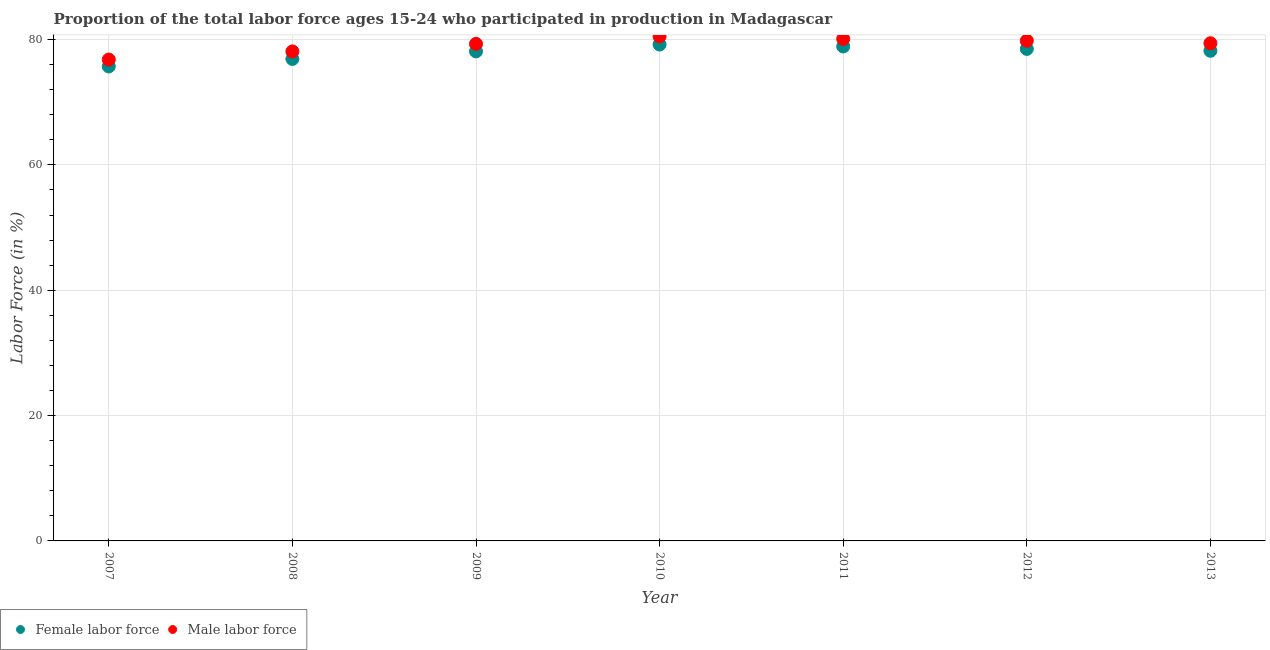How many different coloured dotlines are there?
Make the answer very short. 2. What is the percentage of female labor force in 2010?
Your answer should be compact. 79.2. Across all years, what is the maximum percentage of female labor force?
Your answer should be very brief. 79.2. Across all years, what is the minimum percentage of male labour force?
Your answer should be very brief. 76.8. In which year was the percentage of female labor force maximum?
Offer a terse response. 2010. What is the total percentage of female labor force in the graph?
Ensure brevity in your answer.  545.5. What is the difference between the percentage of male labour force in 2008 and that in 2010?
Give a very brief answer. -2.4. What is the difference between the percentage of male labour force in 2010 and the percentage of female labor force in 2013?
Offer a terse response. 2.3. What is the average percentage of male labour force per year?
Provide a succinct answer. 79.14. In the year 2009, what is the difference between the percentage of female labor force and percentage of male labour force?
Ensure brevity in your answer.  -1.2. What is the ratio of the percentage of male labour force in 2008 to that in 2012?
Provide a succinct answer. 0.98. Is the percentage of female labor force in 2007 less than that in 2008?
Offer a very short reply. Yes. Is the difference between the percentage of female labor force in 2011 and 2013 greater than the difference between the percentage of male labour force in 2011 and 2013?
Your answer should be very brief. Yes. What is the difference between the highest and the second highest percentage of male labour force?
Give a very brief answer. 0.4. What is the difference between the highest and the lowest percentage of male labour force?
Give a very brief answer. 3.7. In how many years, is the percentage of male labour force greater than the average percentage of male labour force taken over all years?
Keep it short and to the point. 5. Is the percentage of female labor force strictly less than the percentage of male labour force over the years?
Keep it short and to the point. Yes. How many dotlines are there?
Keep it short and to the point. 2. What is the difference between two consecutive major ticks on the Y-axis?
Offer a very short reply. 20. Does the graph contain any zero values?
Your response must be concise. No. Where does the legend appear in the graph?
Provide a succinct answer. Bottom left. How many legend labels are there?
Offer a terse response. 2. What is the title of the graph?
Ensure brevity in your answer.  Proportion of the total labor force ages 15-24 who participated in production in Madagascar. What is the Labor Force (in %) of Female labor force in 2007?
Your answer should be very brief. 75.7. What is the Labor Force (in %) in Male labor force in 2007?
Make the answer very short. 76.8. What is the Labor Force (in %) of Female labor force in 2008?
Offer a terse response. 76.9. What is the Labor Force (in %) of Male labor force in 2008?
Your response must be concise. 78.1. What is the Labor Force (in %) of Female labor force in 2009?
Your answer should be very brief. 78.1. What is the Labor Force (in %) of Male labor force in 2009?
Offer a terse response. 79.3. What is the Labor Force (in %) in Female labor force in 2010?
Offer a terse response. 79.2. What is the Labor Force (in %) of Male labor force in 2010?
Your response must be concise. 80.5. What is the Labor Force (in %) in Female labor force in 2011?
Ensure brevity in your answer.  78.9. What is the Labor Force (in %) in Male labor force in 2011?
Keep it short and to the point. 80.1. What is the Labor Force (in %) of Female labor force in 2012?
Offer a very short reply. 78.5. What is the Labor Force (in %) of Male labor force in 2012?
Your answer should be compact. 79.8. What is the Labor Force (in %) of Female labor force in 2013?
Give a very brief answer. 78.2. What is the Labor Force (in %) in Male labor force in 2013?
Offer a very short reply. 79.4. Across all years, what is the maximum Labor Force (in %) in Female labor force?
Ensure brevity in your answer.  79.2. Across all years, what is the maximum Labor Force (in %) in Male labor force?
Offer a terse response. 80.5. Across all years, what is the minimum Labor Force (in %) of Female labor force?
Keep it short and to the point. 75.7. Across all years, what is the minimum Labor Force (in %) of Male labor force?
Your answer should be compact. 76.8. What is the total Labor Force (in %) of Female labor force in the graph?
Make the answer very short. 545.5. What is the total Labor Force (in %) in Male labor force in the graph?
Give a very brief answer. 554. What is the difference between the Labor Force (in %) in Female labor force in 2007 and that in 2008?
Your answer should be compact. -1.2. What is the difference between the Labor Force (in %) of Male labor force in 2007 and that in 2009?
Make the answer very short. -2.5. What is the difference between the Labor Force (in %) of Female labor force in 2007 and that in 2010?
Keep it short and to the point. -3.5. What is the difference between the Labor Force (in %) of Male labor force in 2007 and that in 2011?
Offer a very short reply. -3.3. What is the difference between the Labor Force (in %) of Male labor force in 2007 and that in 2012?
Give a very brief answer. -3. What is the difference between the Labor Force (in %) in Female labor force in 2007 and that in 2013?
Offer a very short reply. -2.5. What is the difference between the Labor Force (in %) of Male labor force in 2008 and that in 2010?
Offer a very short reply. -2.4. What is the difference between the Labor Force (in %) in Female labor force in 2008 and that in 2011?
Your response must be concise. -2. What is the difference between the Labor Force (in %) of Male labor force in 2008 and that in 2011?
Offer a terse response. -2. What is the difference between the Labor Force (in %) in Female labor force in 2008 and that in 2012?
Your response must be concise. -1.6. What is the difference between the Labor Force (in %) in Female labor force in 2009 and that in 2011?
Your answer should be compact. -0.8. What is the difference between the Labor Force (in %) in Male labor force in 2009 and that in 2012?
Your answer should be compact. -0.5. What is the difference between the Labor Force (in %) in Female labor force in 2009 and that in 2013?
Offer a terse response. -0.1. What is the difference between the Labor Force (in %) of Female labor force in 2010 and that in 2013?
Give a very brief answer. 1. What is the difference between the Labor Force (in %) in Male labor force in 2010 and that in 2013?
Provide a short and direct response. 1.1. What is the difference between the Labor Force (in %) of Male labor force in 2011 and that in 2012?
Offer a very short reply. 0.3. What is the difference between the Labor Force (in %) in Male labor force in 2011 and that in 2013?
Your response must be concise. 0.7. What is the difference between the Labor Force (in %) in Female labor force in 2007 and the Labor Force (in %) in Male labor force in 2009?
Give a very brief answer. -3.6. What is the difference between the Labor Force (in %) in Female labor force in 2007 and the Labor Force (in %) in Male labor force in 2011?
Your answer should be compact. -4.4. What is the difference between the Labor Force (in %) of Female labor force in 2008 and the Labor Force (in %) of Male labor force in 2011?
Your answer should be very brief. -3.2. What is the difference between the Labor Force (in %) in Female labor force in 2009 and the Labor Force (in %) in Male labor force in 2010?
Ensure brevity in your answer.  -2.4. What is the difference between the Labor Force (in %) in Female labor force in 2009 and the Labor Force (in %) in Male labor force in 2013?
Offer a terse response. -1.3. What is the difference between the Labor Force (in %) in Female labor force in 2011 and the Labor Force (in %) in Male labor force in 2012?
Ensure brevity in your answer.  -0.9. What is the average Labor Force (in %) of Female labor force per year?
Your answer should be very brief. 77.93. What is the average Labor Force (in %) of Male labor force per year?
Keep it short and to the point. 79.14. In the year 2007, what is the difference between the Labor Force (in %) of Female labor force and Labor Force (in %) of Male labor force?
Your response must be concise. -1.1. In the year 2008, what is the difference between the Labor Force (in %) in Female labor force and Labor Force (in %) in Male labor force?
Offer a very short reply. -1.2. In the year 2010, what is the difference between the Labor Force (in %) of Female labor force and Labor Force (in %) of Male labor force?
Your answer should be very brief. -1.3. In the year 2012, what is the difference between the Labor Force (in %) in Female labor force and Labor Force (in %) in Male labor force?
Give a very brief answer. -1.3. What is the ratio of the Labor Force (in %) in Female labor force in 2007 to that in 2008?
Provide a succinct answer. 0.98. What is the ratio of the Labor Force (in %) in Male labor force in 2007 to that in 2008?
Keep it short and to the point. 0.98. What is the ratio of the Labor Force (in %) of Female labor force in 2007 to that in 2009?
Keep it short and to the point. 0.97. What is the ratio of the Labor Force (in %) of Male labor force in 2007 to that in 2009?
Provide a succinct answer. 0.97. What is the ratio of the Labor Force (in %) of Female labor force in 2007 to that in 2010?
Your answer should be very brief. 0.96. What is the ratio of the Labor Force (in %) in Male labor force in 2007 to that in 2010?
Ensure brevity in your answer.  0.95. What is the ratio of the Labor Force (in %) of Female labor force in 2007 to that in 2011?
Keep it short and to the point. 0.96. What is the ratio of the Labor Force (in %) of Male labor force in 2007 to that in 2011?
Provide a succinct answer. 0.96. What is the ratio of the Labor Force (in %) of Male labor force in 2007 to that in 2012?
Give a very brief answer. 0.96. What is the ratio of the Labor Force (in %) of Male labor force in 2007 to that in 2013?
Your answer should be compact. 0.97. What is the ratio of the Labor Force (in %) of Female labor force in 2008 to that in 2009?
Provide a succinct answer. 0.98. What is the ratio of the Labor Force (in %) of Male labor force in 2008 to that in 2009?
Your answer should be compact. 0.98. What is the ratio of the Labor Force (in %) in Male labor force in 2008 to that in 2010?
Offer a very short reply. 0.97. What is the ratio of the Labor Force (in %) of Female labor force in 2008 to that in 2011?
Offer a very short reply. 0.97. What is the ratio of the Labor Force (in %) in Female labor force in 2008 to that in 2012?
Offer a very short reply. 0.98. What is the ratio of the Labor Force (in %) in Male labor force in 2008 to that in 2012?
Ensure brevity in your answer.  0.98. What is the ratio of the Labor Force (in %) in Female labor force in 2008 to that in 2013?
Your answer should be very brief. 0.98. What is the ratio of the Labor Force (in %) in Male labor force in 2008 to that in 2013?
Keep it short and to the point. 0.98. What is the ratio of the Labor Force (in %) of Female labor force in 2009 to that in 2010?
Offer a terse response. 0.99. What is the ratio of the Labor Force (in %) of Male labor force in 2009 to that in 2010?
Keep it short and to the point. 0.99. What is the ratio of the Labor Force (in %) in Female labor force in 2009 to that in 2011?
Offer a very short reply. 0.99. What is the ratio of the Labor Force (in %) of Male labor force in 2009 to that in 2011?
Offer a very short reply. 0.99. What is the ratio of the Labor Force (in %) of Female labor force in 2010 to that in 2011?
Your answer should be very brief. 1. What is the ratio of the Labor Force (in %) in Male labor force in 2010 to that in 2011?
Offer a very short reply. 1. What is the ratio of the Labor Force (in %) of Female labor force in 2010 to that in 2012?
Your answer should be compact. 1.01. What is the ratio of the Labor Force (in %) of Male labor force in 2010 to that in 2012?
Keep it short and to the point. 1.01. What is the ratio of the Labor Force (in %) of Female labor force in 2010 to that in 2013?
Make the answer very short. 1.01. What is the ratio of the Labor Force (in %) of Male labor force in 2010 to that in 2013?
Give a very brief answer. 1.01. What is the ratio of the Labor Force (in %) of Male labor force in 2011 to that in 2012?
Offer a very short reply. 1. What is the ratio of the Labor Force (in %) of Female labor force in 2011 to that in 2013?
Offer a terse response. 1.01. What is the ratio of the Labor Force (in %) of Male labor force in 2011 to that in 2013?
Make the answer very short. 1.01. What is the ratio of the Labor Force (in %) of Female labor force in 2012 to that in 2013?
Provide a short and direct response. 1. What is the ratio of the Labor Force (in %) in Male labor force in 2012 to that in 2013?
Offer a terse response. 1. What is the difference between the highest and the lowest Labor Force (in %) of Female labor force?
Give a very brief answer. 3.5. 